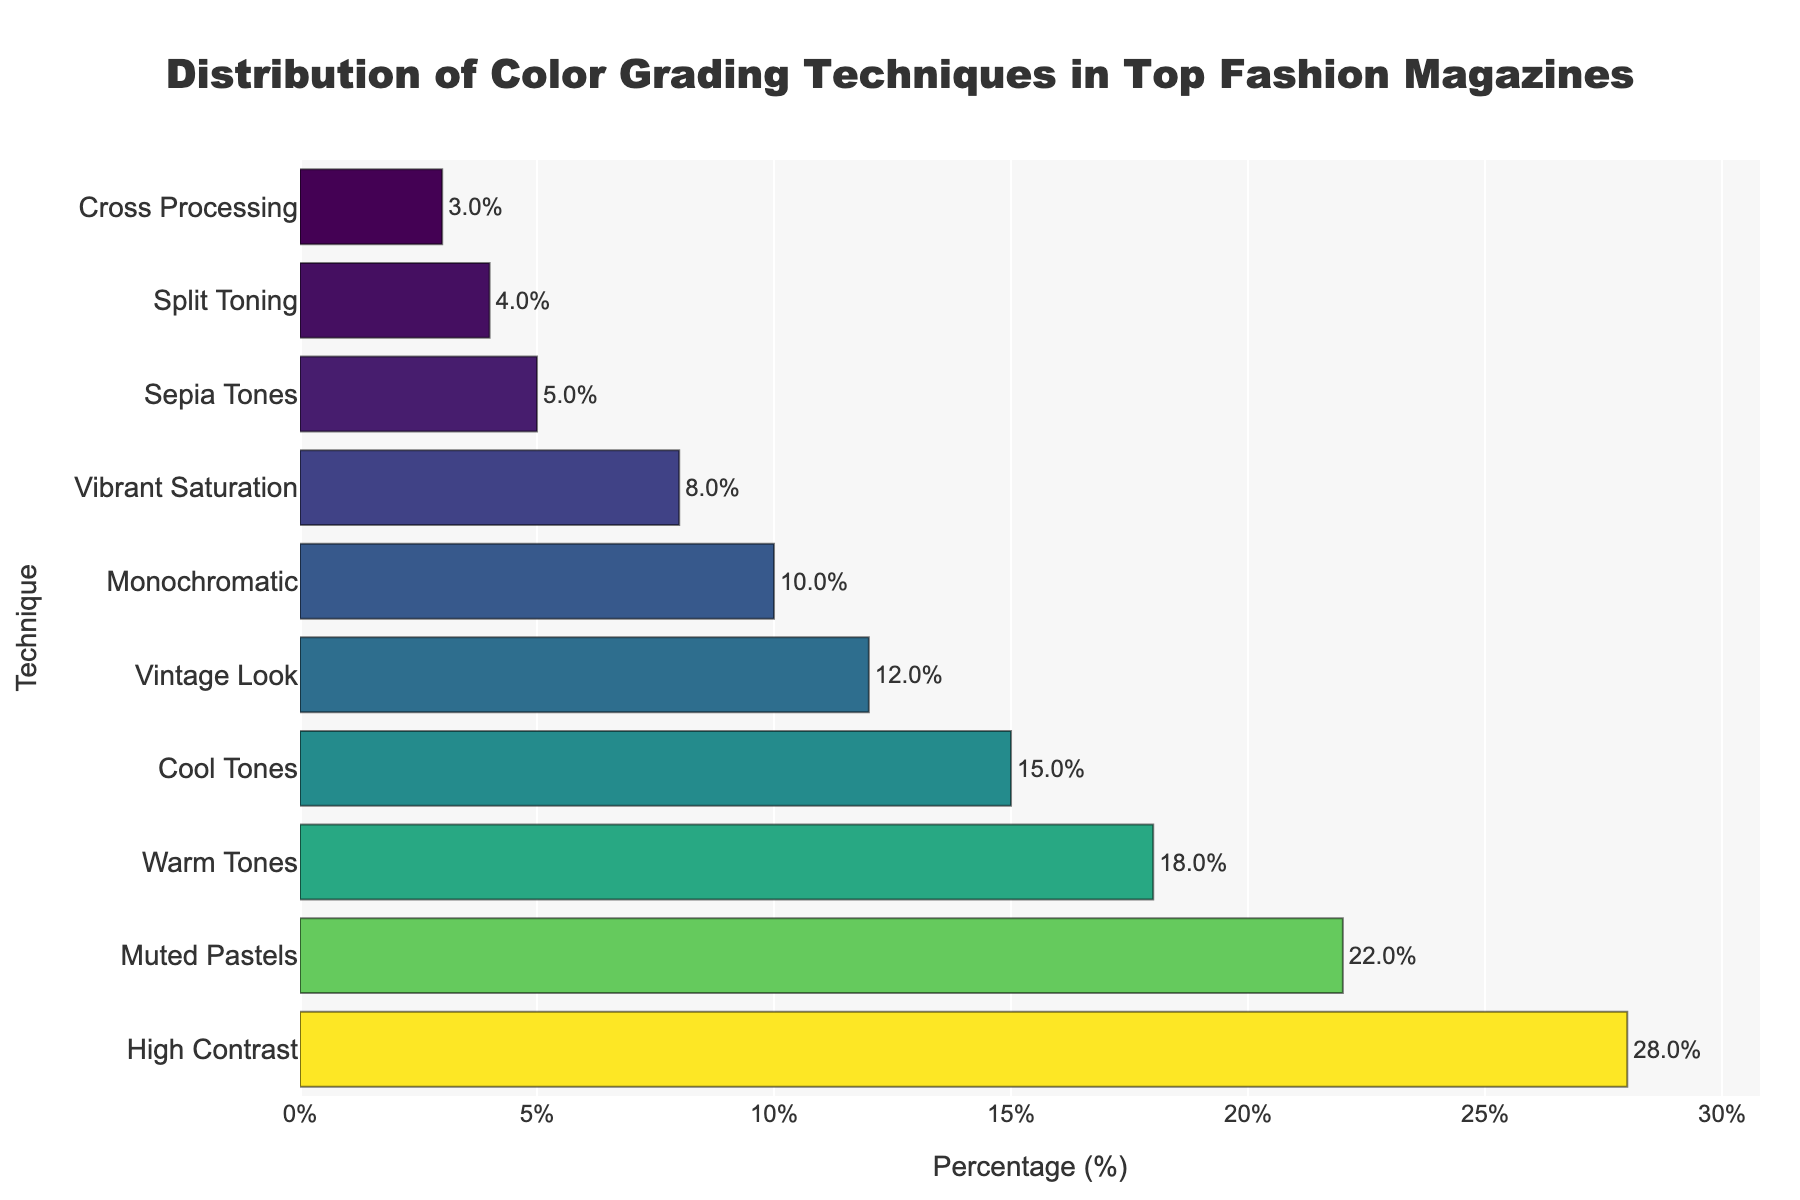Which color grading technique is the most frequently used by top fashion magazines? The highest bar in the chart represents the technique with the highest percentage. In this case, it is the "High Contrast" technique.
Answer: High Contrast Which color grading technique is the least frequently used by top fashion magazines? The smallest bar in the chart represents the technique with the lowest percentage. That is the "Cross Processing" technique.
Answer: Cross Processing What is the combined percentage of Warm Tones and Cool Tones usage? According to the bar chart, Warm Tones is 18% and Cool Tones is 15%. Their combined percentage is 18% + 15% = 33%.
Answer: 33% How much higher is the percentage usage of High Contrast compared to Vibrant Saturation? High Contrast is at 28%, and Vibrant Saturation is at 8%. The difference is 28% - 8% = 20%.
Answer: 20% Which has a higher percentage, Muted Pastels or Warm Tones, and by how much? Muted Pastels is at 22%, while Warm Tones is at 18%. The difference is 22% - 18% = 4%.
Answer: Muted Pastels, 4% What is the average percentage usage of Sepia Tones, Split Toning, and Cross Processing? Sepia Tones is 5%, Split Toning is 4%, and Cross Processing is 3%. The average is (5% + 4% + 3%) / 3 = 4%.
Answer: 4% How does the percentage of Monochromatic compare to the percentage of Vintage Look? Monochromatic is at 10%, and Vintage Look is at 12%. Monochromatic is 2% less than Vintage Look.
Answer: Less by 2% What percentage of techniques have usage rates below 10%? Listing the techniques with percentages below 10%: Vibrant Saturation (8%), Sepia Tones (5%), Split Toning (4%), Cross Processing (3%). There are 4 out of 10 techniques, which is 40%.
Answer: 40% What is the median percentage value for the distribution of all color grading techniques? The sorted values are: 3, 4, 5, 8, 10, 12, 15, 18, 22, 28. The median value (middle value in an ordered list) for 10 data points is the average of the 5th and 6th values. (10% + 12%) / 2 = 11%.
Answer: 11% How much higher is the highest percentage compared to the lowest percentage in the chart? The highest percentage is 28% for High Contrast, and the lowest is 3% for Cross Processing. The difference is 28% - 3% = 25%.
Answer: 25% 